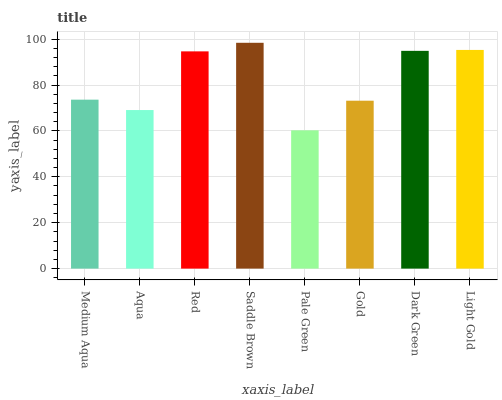Is Pale Green the minimum?
Answer yes or no. Yes. Is Saddle Brown the maximum?
Answer yes or no. Yes. Is Aqua the minimum?
Answer yes or no. No. Is Aqua the maximum?
Answer yes or no. No. Is Medium Aqua greater than Aqua?
Answer yes or no. Yes. Is Aqua less than Medium Aqua?
Answer yes or no. Yes. Is Aqua greater than Medium Aqua?
Answer yes or no. No. Is Medium Aqua less than Aqua?
Answer yes or no. No. Is Red the high median?
Answer yes or no. Yes. Is Medium Aqua the low median?
Answer yes or no. Yes. Is Medium Aqua the high median?
Answer yes or no. No. Is Saddle Brown the low median?
Answer yes or no. No. 